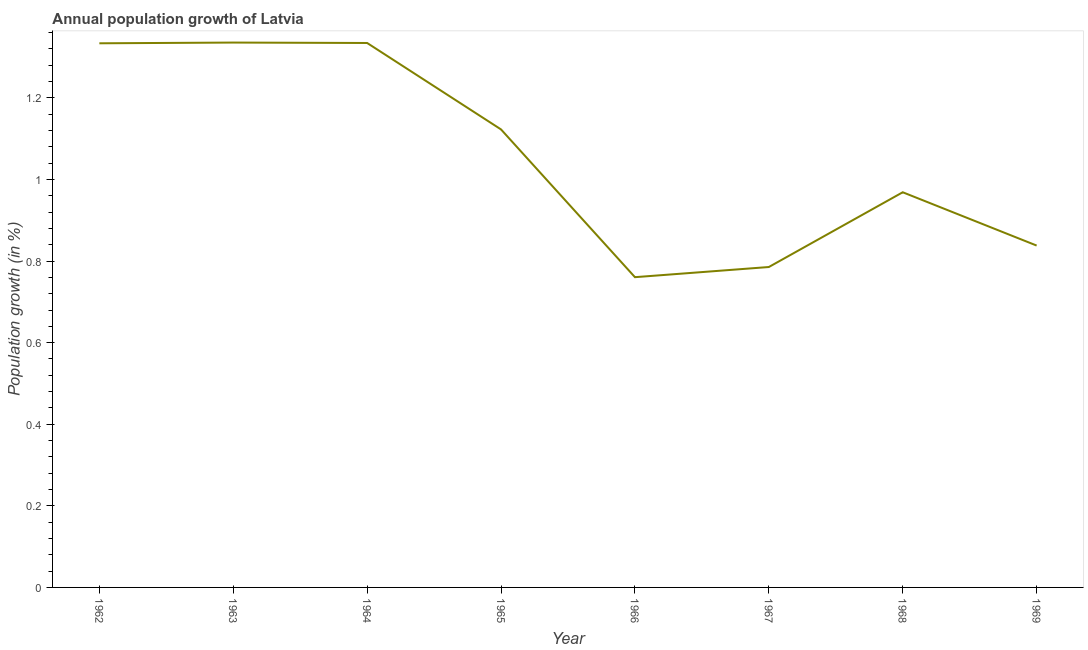What is the population growth in 1966?
Offer a terse response. 0.76. Across all years, what is the maximum population growth?
Your response must be concise. 1.34. Across all years, what is the minimum population growth?
Your answer should be compact. 0.76. In which year was the population growth maximum?
Offer a terse response. 1963. In which year was the population growth minimum?
Your response must be concise. 1966. What is the sum of the population growth?
Ensure brevity in your answer.  8.48. What is the difference between the population growth in 1964 and 1965?
Your answer should be compact. 0.21. What is the average population growth per year?
Make the answer very short. 1.06. What is the median population growth?
Offer a very short reply. 1.05. In how many years, is the population growth greater than 1 %?
Make the answer very short. 4. What is the ratio of the population growth in 1962 to that in 1967?
Provide a succinct answer. 1.7. Is the population growth in 1963 less than that in 1966?
Offer a very short reply. No. Is the difference between the population growth in 1965 and 1966 greater than the difference between any two years?
Make the answer very short. No. What is the difference between the highest and the second highest population growth?
Provide a short and direct response. 0. What is the difference between the highest and the lowest population growth?
Make the answer very short. 0.58. In how many years, is the population growth greater than the average population growth taken over all years?
Offer a very short reply. 4. Does the population growth monotonically increase over the years?
Offer a terse response. No. What is the difference between two consecutive major ticks on the Y-axis?
Offer a terse response. 0.2. Are the values on the major ticks of Y-axis written in scientific E-notation?
Ensure brevity in your answer.  No. What is the title of the graph?
Ensure brevity in your answer.  Annual population growth of Latvia. What is the label or title of the Y-axis?
Offer a very short reply. Population growth (in %). What is the Population growth (in %) of 1962?
Provide a short and direct response. 1.33. What is the Population growth (in %) of 1963?
Keep it short and to the point. 1.34. What is the Population growth (in %) of 1964?
Your answer should be compact. 1.33. What is the Population growth (in %) in 1965?
Provide a succinct answer. 1.12. What is the Population growth (in %) of 1966?
Ensure brevity in your answer.  0.76. What is the Population growth (in %) of 1967?
Offer a very short reply. 0.79. What is the Population growth (in %) in 1968?
Provide a succinct answer. 0.97. What is the Population growth (in %) in 1969?
Make the answer very short. 0.84. What is the difference between the Population growth (in %) in 1962 and 1963?
Your answer should be compact. -0. What is the difference between the Population growth (in %) in 1962 and 1964?
Make the answer very short. -0. What is the difference between the Population growth (in %) in 1962 and 1965?
Provide a succinct answer. 0.21. What is the difference between the Population growth (in %) in 1962 and 1966?
Provide a succinct answer. 0.57. What is the difference between the Population growth (in %) in 1962 and 1967?
Your answer should be very brief. 0.55. What is the difference between the Population growth (in %) in 1962 and 1968?
Offer a very short reply. 0.37. What is the difference between the Population growth (in %) in 1962 and 1969?
Your answer should be compact. 0.5. What is the difference between the Population growth (in %) in 1963 and 1964?
Keep it short and to the point. 0. What is the difference between the Population growth (in %) in 1963 and 1965?
Offer a very short reply. 0.21. What is the difference between the Population growth (in %) in 1963 and 1966?
Keep it short and to the point. 0.58. What is the difference between the Population growth (in %) in 1963 and 1967?
Give a very brief answer. 0.55. What is the difference between the Population growth (in %) in 1963 and 1968?
Offer a terse response. 0.37. What is the difference between the Population growth (in %) in 1963 and 1969?
Give a very brief answer. 0.5. What is the difference between the Population growth (in %) in 1964 and 1965?
Your answer should be compact. 0.21. What is the difference between the Population growth (in %) in 1964 and 1966?
Ensure brevity in your answer.  0.57. What is the difference between the Population growth (in %) in 1964 and 1967?
Offer a very short reply. 0.55. What is the difference between the Population growth (in %) in 1964 and 1968?
Provide a succinct answer. 0.37. What is the difference between the Population growth (in %) in 1964 and 1969?
Your response must be concise. 0.5. What is the difference between the Population growth (in %) in 1965 and 1966?
Your response must be concise. 0.36. What is the difference between the Population growth (in %) in 1965 and 1967?
Provide a succinct answer. 0.34. What is the difference between the Population growth (in %) in 1965 and 1968?
Your answer should be compact. 0.15. What is the difference between the Population growth (in %) in 1965 and 1969?
Your response must be concise. 0.28. What is the difference between the Population growth (in %) in 1966 and 1967?
Your answer should be very brief. -0.02. What is the difference between the Population growth (in %) in 1966 and 1968?
Make the answer very short. -0.21. What is the difference between the Population growth (in %) in 1966 and 1969?
Provide a succinct answer. -0.08. What is the difference between the Population growth (in %) in 1967 and 1968?
Give a very brief answer. -0.18. What is the difference between the Population growth (in %) in 1967 and 1969?
Provide a short and direct response. -0.05. What is the difference between the Population growth (in %) in 1968 and 1969?
Keep it short and to the point. 0.13. What is the ratio of the Population growth (in %) in 1962 to that in 1964?
Provide a short and direct response. 1. What is the ratio of the Population growth (in %) in 1962 to that in 1965?
Your answer should be very brief. 1.19. What is the ratio of the Population growth (in %) in 1962 to that in 1966?
Make the answer very short. 1.75. What is the ratio of the Population growth (in %) in 1962 to that in 1967?
Offer a terse response. 1.7. What is the ratio of the Population growth (in %) in 1962 to that in 1968?
Give a very brief answer. 1.38. What is the ratio of the Population growth (in %) in 1962 to that in 1969?
Provide a succinct answer. 1.59. What is the ratio of the Population growth (in %) in 1963 to that in 1964?
Provide a short and direct response. 1. What is the ratio of the Population growth (in %) in 1963 to that in 1965?
Offer a very short reply. 1.19. What is the ratio of the Population growth (in %) in 1963 to that in 1966?
Provide a succinct answer. 1.76. What is the ratio of the Population growth (in %) in 1963 to that in 1967?
Make the answer very short. 1.7. What is the ratio of the Population growth (in %) in 1963 to that in 1968?
Your response must be concise. 1.38. What is the ratio of the Population growth (in %) in 1963 to that in 1969?
Make the answer very short. 1.59. What is the ratio of the Population growth (in %) in 1964 to that in 1965?
Offer a terse response. 1.19. What is the ratio of the Population growth (in %) in 1964 to that in 1966?
Provide a succinct answer. 1.75. What is the ratio of the Population growth (in %) in 1964 to that in 1967?
Your answer should be compact. 1.7. What is the ratio of the Population growth (in %) in 1964 to that in 1968?
Give a very brief answer. 1.38. What is the ratio of the Population growth (in %) in 1964 to that in 1969?
Ensure brevity in your answer.  1.59. What is the ratio of the Population growth (in %) in 1965 to that in 1966?
Your answer should be compact. 1.48. What is the ratio of the Population growth (in %) in 1965 to that in 1967?
Your response must be concise. 1.43. What is the ratio of the Population growth (in %) in 1965 to that in 1968?
Make the answer very short. 1.16. What is the ratio of the Population growth (in %) in 1965 to that in 1969?
Give a very brief answer. 1.34. What is the ratio of the Population growth (in %) in 1966 to that in 1968?
Provide a short and direct response. 0.79. What is the ratio of the Population growth (in %) in 1966 to that in 1969?
Provide a succinct answer. 0.91. What is the ratio of the Population growth (in %) in 1967 to that in 1968?
Offer a very short reply. 0.81. What is the ratio of the Population growth (in %) in 1967 to that in 1969?
Your answer should be compact. 0.94. What is the ratio of the Population growth (in %) in 1968 to that in 1969?
Your answer should be very brief. 1.16. 